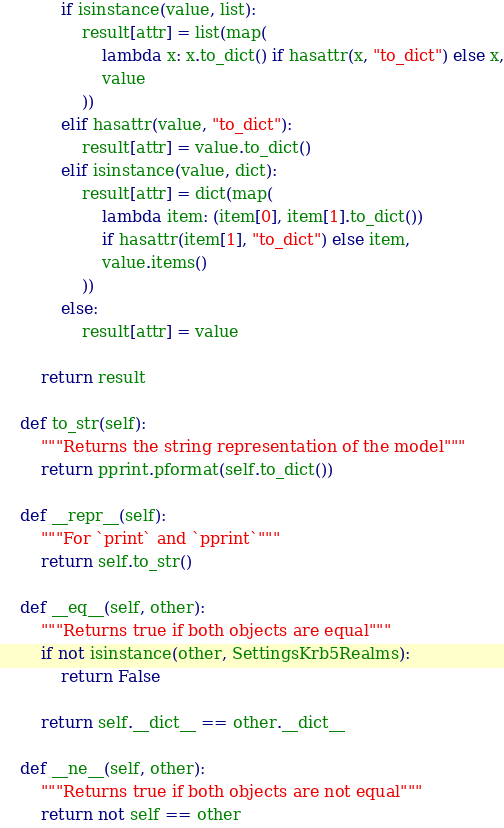<code> <loc_0><loc_0><loc_500><loc_500><_Python_>            if isinstance(value, list):
                result[attr] = list(map(
                    lambda x: x.to_dict() if hasattr(x, "to_dict") else x,
                    value
                ))
            elif hasattr(value, "to_dict"):
                result[attr] = value.to_dict()
            elif isinstance(value, dict):
                result[attr] = dict(map(
                    lambda item: (item[0], item[1].to_dict())
                    if hasattr(item[1], "to_dict") else item,
                    value.items()
                ))
            else:
                result[attr] = value

        return result

    def to_str(self):
        """Returns the string representation of the model"""
        return pprint.pformat(self.to_dict())

    def __repr__(self):
        """For `print` and `pprint`"""
        return self.to_str()

    def __eq__(self, other):
        """Returns true if both objects are equal"""
        if not isinstance(other, SettingsKrb5Realms):
            return False

        return self.__dict__ == other.__dict__

    def __ne__(self, other):
        """Returns true if both objects are not equal"""
        return not self == other
</code> 